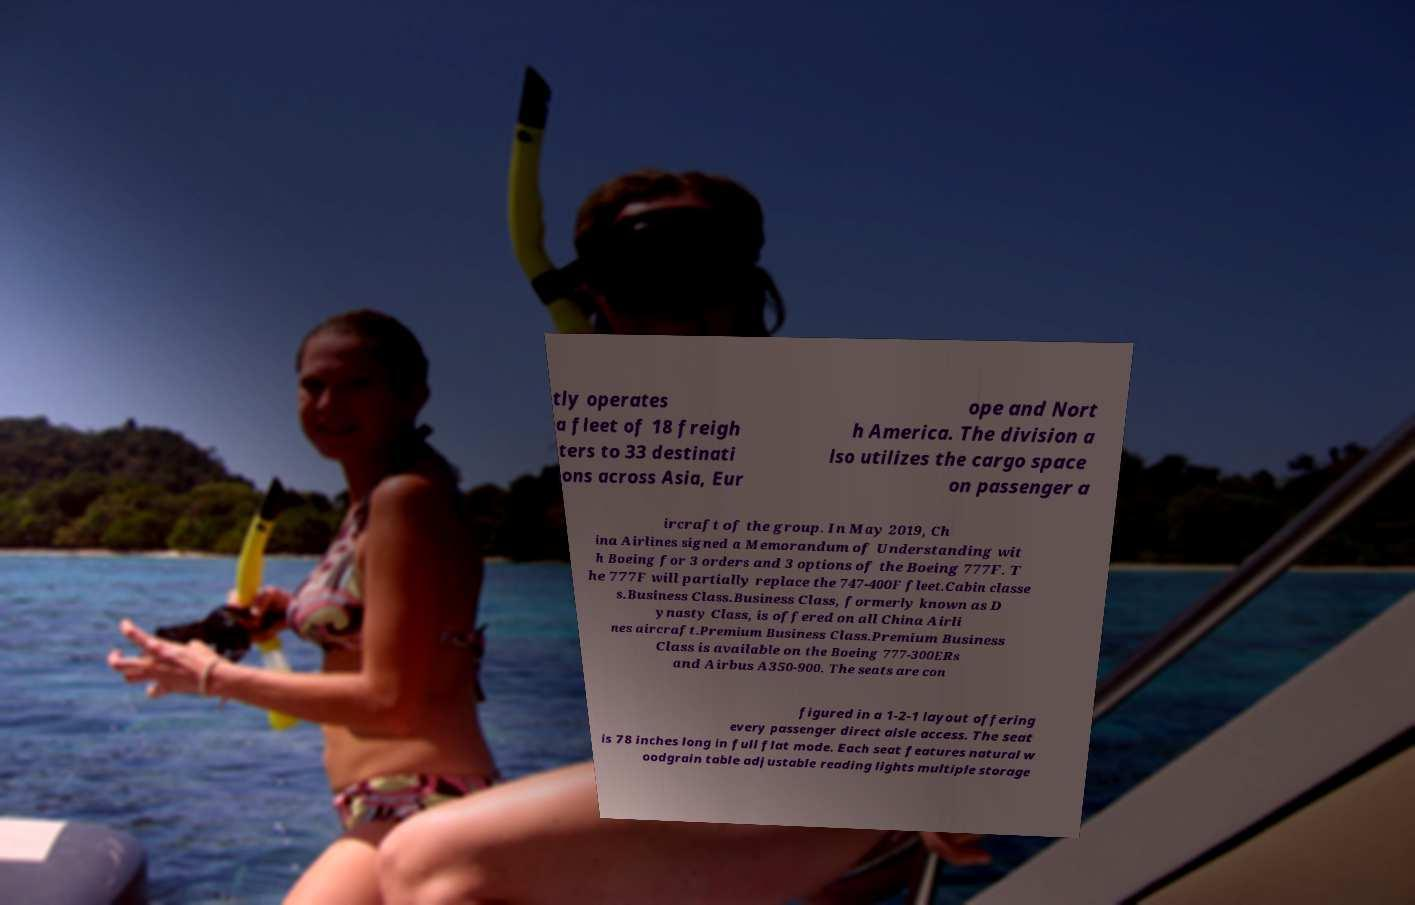For documentation purposes, I need the text within this image transcribed. Could you provide that? tly operates a fleet of 18 freigh ters to 33 destinati ons across Asia, Eur ope and Nort h America. The division a lso utilizes the cargo space on passenger a ircraft of the group. In May 2019, Ch ina Airlines signed a Memorandum of Understanding wit h Boeing for 3 orders and 3 options of the Boeing 777F. T he 777F will partially replace the 747-400F fleet.Cabin classe s.Business Class.Business Class, formerly known as D ynasty Class, is offered on all China Airli nes aircraft.Premium Business Class.Premium Business Class is available on the Boeing 777-300ERs and Airbus A350-900. The seats are con figured in a 1-2-1 layout offering every passenger direct aisle access. The seat is 78 inches long in full flat mode. Each seat features natural w oodgrain table adjustable reading lights multiple storage 